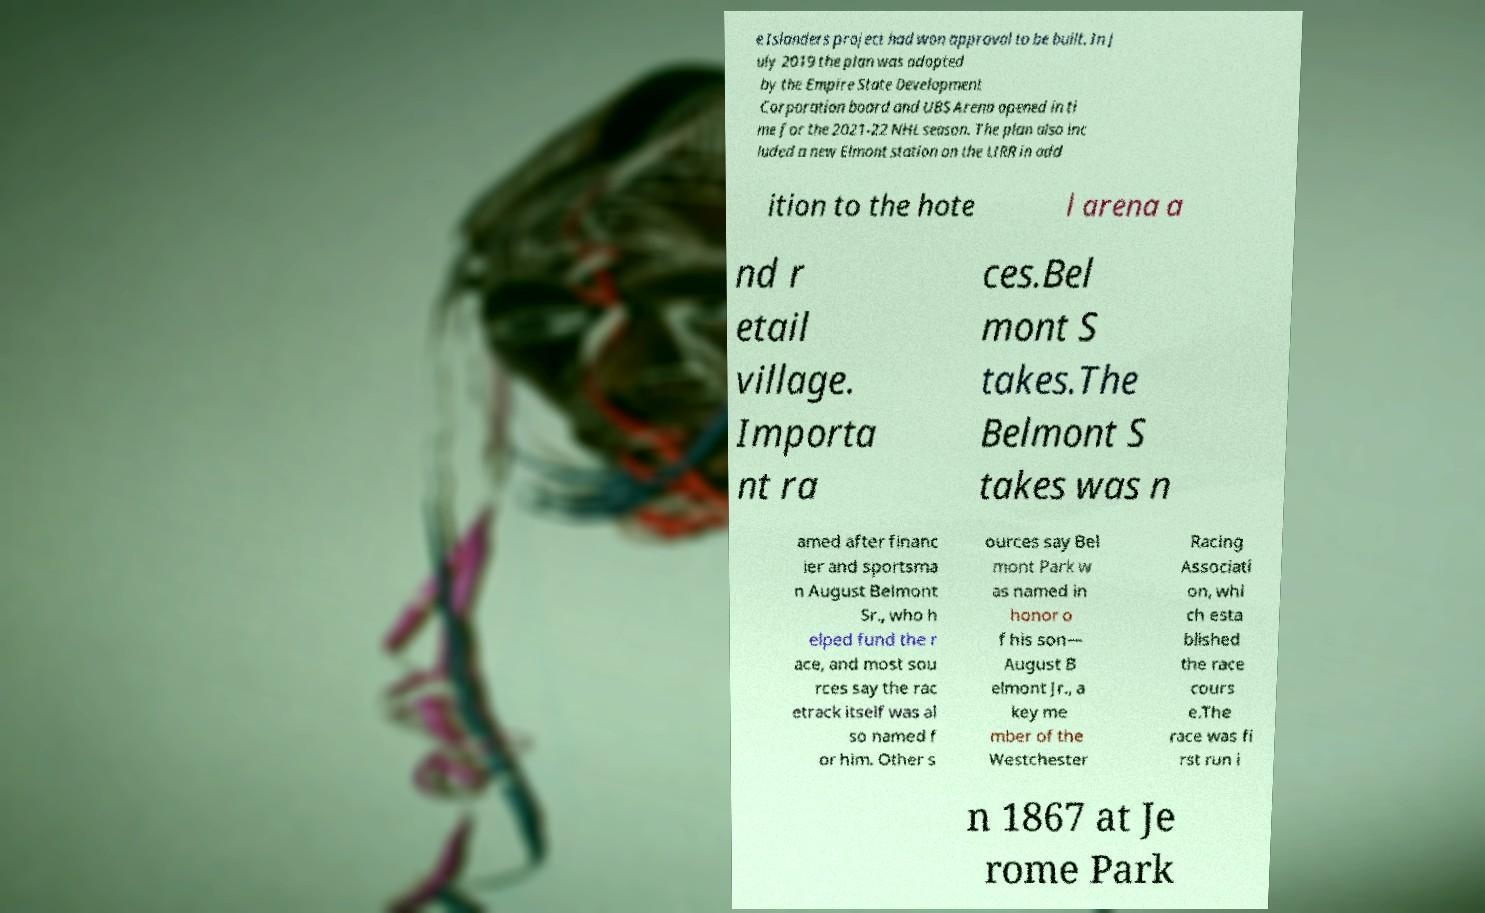Can you accurately transcribe the text from the provided image for me? e Islanders project had won approval to be built. In J uly 2019 the plan was adopted by the Empire State Development Corporation board and UBS Arena opened in ti me for the 2021-22 NHL season. The plan also inc luded a new Elmont station on the LIRR in add ition to the hote l arena a nd r etail village. Importa nt ra ces.Bel mont S takes.The Belmont S takes was n amed after financ ier and sportsma n August Belmont Sr., who h elped fund the r ace, and most sou rces say the rac etrack itself was al so named f or him. Other s ources say Bel mont Park w as named in honor o f his son— August B elmont Jr., a key me mber of the Westchester Racing Associati on, whi ch esta blished the race cours e.The race was fi rst run i n 1867 at Je rome Park 